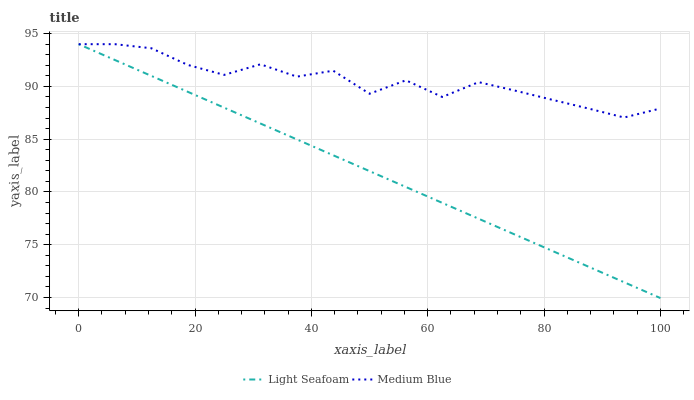Does Light Seafoam have the minimum area under the curve?
Answer yes or no. Yes. Does Medium Blue have the maximum area under the curve?
Answer yes or no. Yes. Does Medium Blue have the minimum area under the curve?
Answer yes or no. No. Is Light Seafoam the smoothest?
Answer yes or no. Yes. Is Medium Blue the roughest?
Answer yes or no. Yes. Is Medium Blue the smoothest?
Answer yes or no. No. Does Light Seafoam have the lowest value?
Answer yes or no. Yes. Does Medium Blue have the lowest value?
Answer yes or no. No. Does Medium Blue have the highest value?
Answer yes or no. Yes. Does Light Seafoam intersect Medium Blue?
Answer yes or no. Yes. Is Light Seafoam less than Medium Blue?
Answer yes or no. No. Is Light Seafoam greater than Medium Blue?
Answer yes or no. No. 